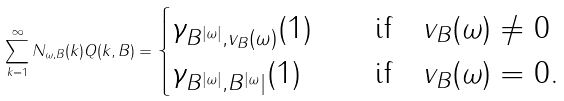Convert formula to latex. <formula><loc_0><loc_0><loc_500><loc_500>\sum _ { k = 1 } ^ { \infty } N _ { \omega , B } ( k ) Q ( k , B ) = \begin{cases} \gamma _ { B ^ { | \omega | } , v _ { B } ( \omega ) } ( 1 ) & \quad \text {if} \quad v _ { B } ( \omega ) \ne 0 \\ \gamma _ { B ^ { | \omega | } , B ^ { | \omega } | } ( 1 ) & \quad \text {if} \quad v _ { B } ( \omega ) = 0 . \end{cases}</formula> 